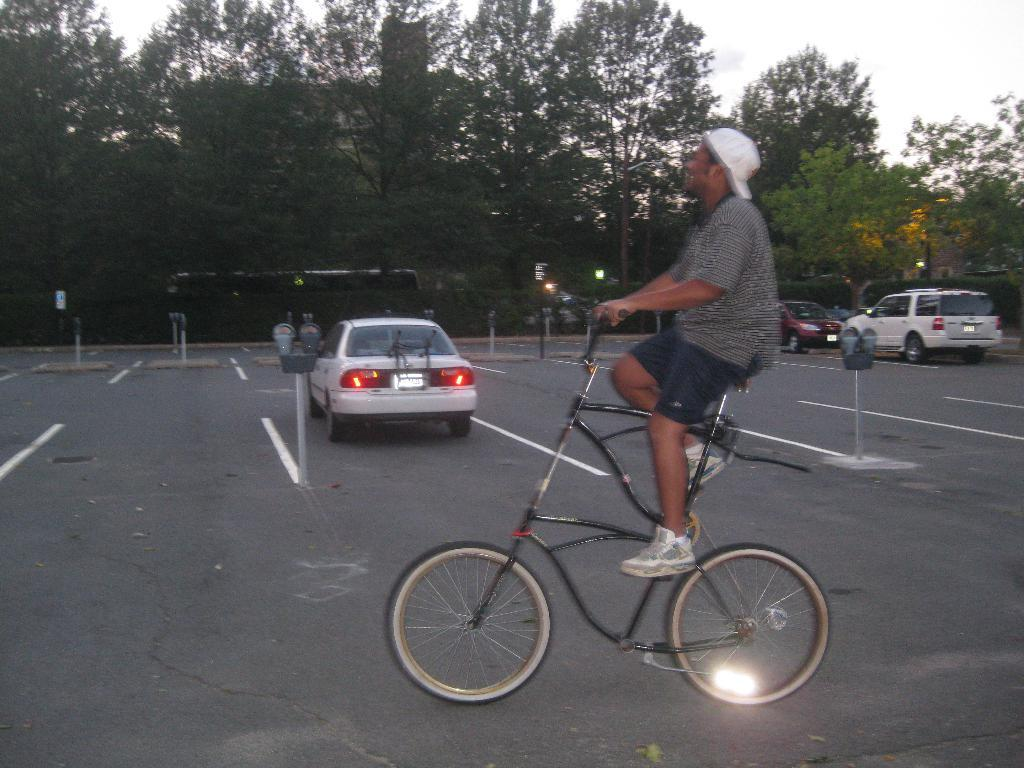What is the main subject of the image? There is a person riding a bicycle in the image. What type of footwear is the person wearing? The person is wearing shoes. What type of headwear is the person wearing? The person is wearing a cap. What can be seen on the road in the image? There are vehicles on the road in the image. What type of vegetation is visible in the background of the image? There are trees visible in the background of the image. What is visible in the sky in the background of the image? The sky is visible in the background of the image. Is the person riding the bicycle through a crate in the image? There is no crate present in the image, so the person is not riding the bicycle through a crate. How deep is the quicksand that the person is riding the bicycle through in the image? There is no quicksand present in the image, so the person is not riding the bicycle through quicksand. 